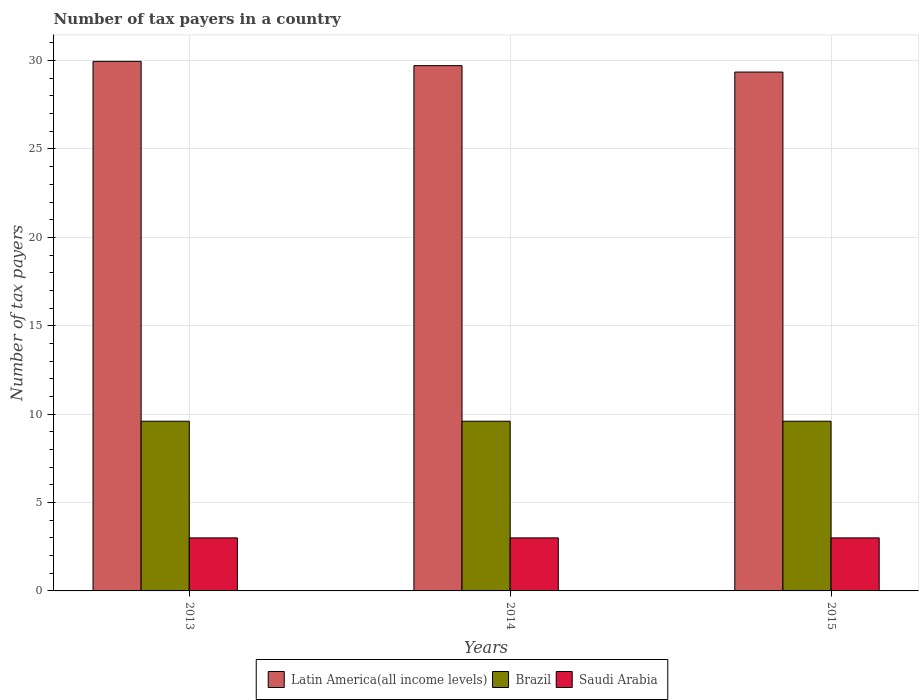How many groups of bars are there?
Ensure brevity in your answer.  3. Are the number of bars on each tick of the X-axis equal?
Give a very brief answer. Yes. How many bars are there on the 1st tick from the right?
Make the answer very short. 3. What is the label of the 2nd group of bars from the left?
Your answer should be very brief. 2014. In how many cases, is the number of bars for a given year not equal to the number of legend labels?
Offer a very short reply. 0. What is the number of tax payers in in Saudi Arabia in 2014?
Your answer should be compact. 3. Across all years, what is the maximum number of tax payers in in Saudi Arabia?
Offer a very short reply. 3. In which year was the number of tax payers in in Latin America(all income levels) maximum?
Ensure brevity in your answer.  2013. In which year was the number of tax payers in in Latin America(all income levels) minimum?
Ensure brevity in your answer.  2015. What is the total number of tax payers in in Latin America(all income levels) in the graph?
Your answer should be compact. 89.02. What is the difference between the number of tax payers in in Latin America(all income levels) in 2013 and that in 2015?
Ensure brevity in your answer.  0.61. What is the difference between the number of tax payers in in Latin America(all income levels) in 2014 and the number of tax payers in in Brazil in 2013?
Offer a very short reply. 20.12. In the year 2014, what is the difference between the number of tax payers in in Brazil and number of tax payers in in Latin America(all income levels)?
Ensure brevity in your answer.  -20.12. Is the difference between the number of tax payers in in Brazil in 2014 and 2015 greater than the difference between the number of tax payers in in Latin America(all income levels) in 2014 and 2015?
Your answer should be very brief. No. What is the difference between the highest and the second highest number of tax payers in in Latin America(all income levels)?
Give a very brief answer. 0.24. What is the difference between the highest and the lowest number of tax payers in in Latin America(all income levels)?
Ensure brevity in your answer.  0.61. In how many years, is the number of tax payers in in Brazil greater than the average number of tax payers in in Brazil taken over all years?
Your answer should be very brief. 0. What does the 2nd bar from the left in 2013 represents?
Give a very brief answer. Brazil. What does the 2nd bar from the right in 2013 represents?
Ensure brevity in your answer.  Brazil. Is it the case that in every year, the sum of the number of tax payers in in Latin America(all income levels) and number of tax payers in in Brazil is greater than the number of tax payers in in Saudi Arabia?
Provide a succinct answer. Yes. Are all the bars in the graph horizontal?
Your answer should be very brief. No. What is the difference between two consecutive major ticks on the Y-axis?
Give a very brief answer. 5. Does the graph contain grids?
Provide a succinct answer. Yes. How many legend labels are there?
Offer a terse response. 3. How are the legend labels stacked?
Provide a succinct answer. Horizontal. What is the title of the graph?
Offer a terse response. Number of tax payers in a country. What is the label or title of the X-axis?
Give a very brief answer. Years. What is the label or title of the Y-axis?
Ensure brevity in your answer.  Number of tax payers. What is the Number of tax payers of Latin America(all income levels) in 2013?
Offer a terse response. 29.96. What is the Number of tax payers of Latin America(all income levels) in 2014?
Your response must be concise. 29.72. What is the Number of tax payers in Brazil in 2014?
Make the answer very short. 9.6. What is the Number of tax payers in Latin America(all income levels) in 2015?
Give a very brief answer. 29.35. Across all years, what is the maximum Number of tax payers in Latin America(all income levels)?
Offer a terse response. 29.96. Across all years, what is the maximum Number of tax payers in Brazil?
Provide a succinct answer. 9.6. Across all years, what is the maximum Number of tax payers in Saudi Arabia?
Make the answer very short. 3. Across all years, what is the minimum Number of tax payers in Latin America(all income levels)?
Provide a succinct answer. 29.35. Across all years, what is the minimum Number of tax payers of Saudi Arabia?
Make the answer very short. 3. What is the total Number of tax payers in Latin America(all income levels) in the graph?
Give a very brief answer. 89.02. What is the total Number of tax payers of Brazil in the graph?
Ensure brevity in your answer.  28.8. What is the difference between the Number of tax payers in Latin America(all income levels) in 2013 and that in 2014?
Your answer should be very brief. 0.24. What is the difference between the Number of tax payers in Brazil in 2013 and that in 2014?
Offer a terse response. 0. What is the difference between the Number of tax payers in Saudi Arabia in 2013 and that in 2014?
Offer a terse response. 0. What is the difference between the Number of tax payers in Latin America(all income levels) in 2013 and that in 2015?
Your response must be concise. 0.61. What is the difference between the Number of tax payers of Latin America(all income levels) in 2014 and that in 2015?
Your response must be concise. 0.36. What is the difference between the Number of tax payers in Saudi Arabia in 2014 and that in 2015?
Your answer should be compact. 0. What is the difference between the Number of tax payers in Latin America(all income levels) in 2013 and the Number of tax payers in Brazil in 2014?
Your answer should be compact. 20.36. What is the difference between the Number of tax payers of Latin America(all income levels) in 2013 and the Number of tax payers of Saudi Arabia in 2014?
Offer a terse response. 26.96. What is the difference between the Number of tax payers in Latin America(all income levels) in 2013 and the Number of tax payers in Brazil in 2015?
Keep it short and to the point. 20.36. What is the difference between the Number of tax payers in Latin America(all income levels) in 2013 and the Number of tax payers in Saudi Arabia in 2015?
Your answer should be compact. 26.96. What is the difference between the Number of tax payers of Latin America(all income levels) in 2014 and the Number of tax payers of Brazil in 2015?
Your answer should be compact. 20.12. What is the difference between the Number of tax payers in Latin America(all income levels) in 2014 and the Number of tax payers in Saudi Arabia in 2015?
Your answer should be very brief. 26.72. What is the difference between the Number of tax payers of Brazil in 2014 and the Number of tax payers of Saudi Arabia in 2015?
Ensure brevity in your answer.  6.6. What is the average Number of tax payers in Latin America(all income levels) per year?
Provide a short and direct response. 29.67. In the year 2013, what is the difference between the Number of tax payers in Latin America(all income levels) and Number of tax payers in Brazil?
Ensure brevity in your answer.  20.36. In the year 2013, what is the difference between the Number of tax payers of Latin America(all income levels) and Number of tax payers of Saudi Arabia?
Keep it short and to the point. 26.96. In the year 2013, what is the difference between the Number of tax payers of Brazil and Number of tax payers of Saudi Arabia?
Keep it short and to the point. 6.6. In the year 2014, what is the difference between the Number of tax payers in Latin America(all income levels) and Number of tax payers in Brazil?
Your answer should be very brief. 20.12. In the year 2014, what is the difference between the Number of tax payers in Latin America(all income levels) and Number of tax payers in Saudi Arabia?
Provide a short and direct response. 26.72. In the year 2014, what is the difference between the Number of tax payers in Brazil and Number of tax payers in Saudi Arabia?
Keep it short and to the point. 6.6. In the year 2015, what is the difference between the Number of tax payers of Latin America(all income levels) and Number of tax payers of Brazil?
Keep it short and to the point. 19.75. In the year 2015, what is the difference between the Number of tax payers of Latin America(all income levels) and Number of tax payers of Saudi Arabia?
Give a very brief answer. 26.35. In the year 2015, what is the difference between the Number of tax payers in Brazil and Number of tax payers in Saudi Arabia?
Provide a succinct answer. 6.6. What is the ratio of the Number of tax payers of Latin America(all income levels) in 2013 to that in 2014?
Make the answer very short. 1.01. What is the ratio of the Number of tax payers of Latin America(all income levels) in 2013 to that in 2015?
Your response must be concise. 1.02. What is the ratio of the Number of tax payers in Latin America(all income levels) in 2014 to that in 2015?
Offer a very short reply. 1.01. What is the ratio of the Number of tax payers of Brazil in 2014 to that in 2015?
Your answer should be compact. 1. What is the difference between the highest and the second highest Number of tax payers in Latin America(all income levels)?
Your answer should be compact. 0.24. What is the difference between the highest and the second highest Number of tax payers of Brazil?
Provide a succinct answer. 0. What is the difference between the highest and the second highest Number of tax payers in Saudi Arabia?
Offer a terse response. 0. What is the difference between the highest and the lowest Number of tax payers in Latin America(all income levels)?
Your response must be concise. 0.61. What is the difference between the highest and the lowest Number of tax payers in Brazil?
Provide a short and direct response. 0. 